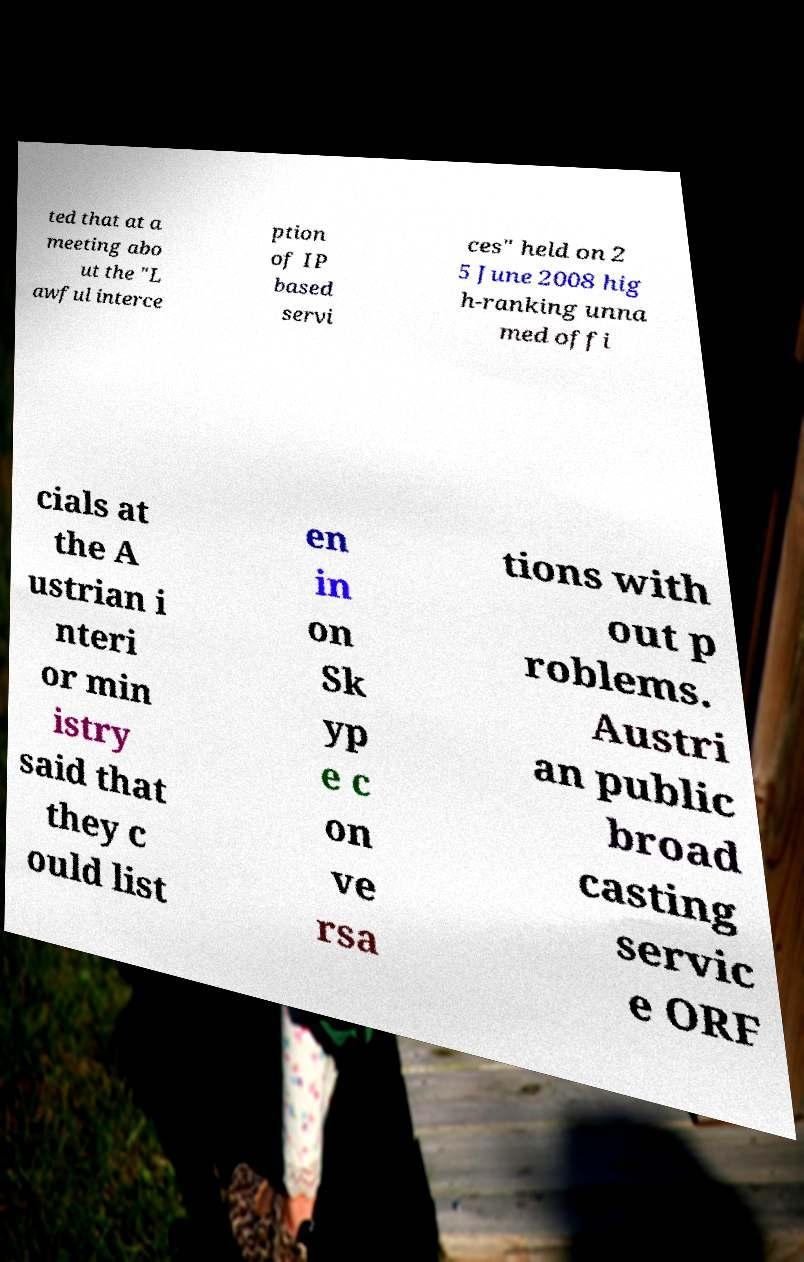There's text embedded in this image that I need extracted. Can you transcribe it verbatim? ted that at a meeting abo ut the "L awful interce ption of IP based servi ces" held on 2 5 June 2008 hig h-ranking unna med offi cials at the A ustrian i nteri or min istry said that they c ould list en in on Sk yp e c on ve rsa tions with out p roblems. Austri an public broad casting servic e ORF 